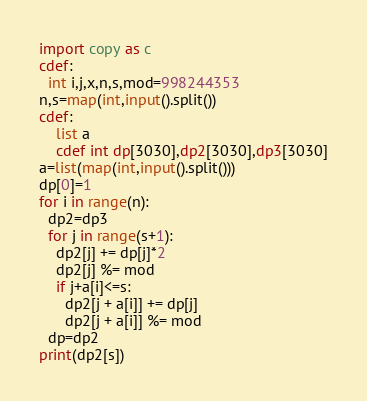<code> <loc_0><loc_0><loc_500><loc_500><_Cython_>import copy as c
cdef:
  int i,j,x,n,s,mod=998244353
n,s=map(int,input().split())
cdef:
    list a
    cdef int dp[3030],dp2[3030],dp3[3030]
a=list(map(int,input().split()))
dp[0]=1
for i in range(n):
  dp2=dp3
  for j in range(s+1):
    dp2[j] += dp[j]*2
    dp2[j] %= mod
    if j+a[i]<=s:
      dp2[j + a[i]] += dp[j]
      dp2[j + a[i]] %= mod
  dp=dp2
print(dp2[s])</code> 